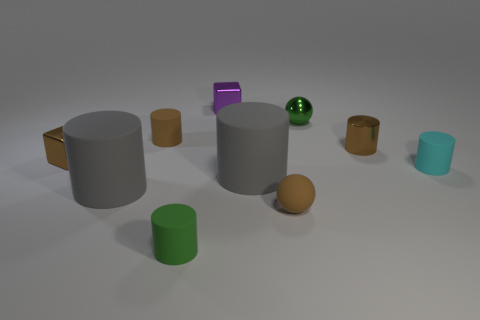The metal object that is the same color as the tiny metal cylinder is what size?
Provide a short and direct response. Small. Do the tiny purple object and the small brown rubber object that is left of the green matte cylinder have the same shape?
Give a very brief answer. No. What material is the small cube that is the same color as the matte ball?
Your answer should be compact. Metal. How many brown things have the same shape as the tiny cyan object?
Offer a very short reply. 2. There is a tiny green metal thing; what shape is it?
Your answer should be very brief. Sphere. Is the number of brown balls less than the number of large matte cylinders?
Ensure brevity in your answer.  Yes. There is a tiny green thing that is the same shape as the tiny cyan thing; what is its material?
Give a very brief answer. Rubber. Are there more purple rubber spheres than tiny brown cylinders?
Make the answer very short. No. What number of other things are the same color as the metallic cylinder?
Your answer should be very brief. 3. Do the cyan cylinder and the tiny green thing that is in front of the tiny matte ball have the same material?
Your response must be concise. Yes. 